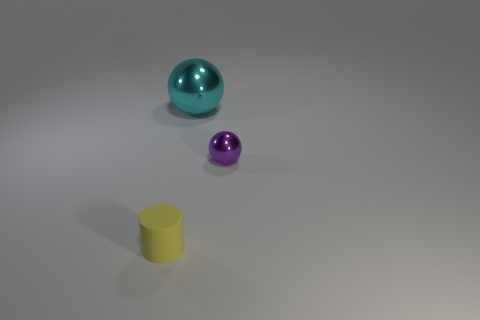Is the tiny purple thing made of the same material as the tiny yellow cylinder?
Your response must be concise. No. There is a small thing that is behind the tiny thing left of the thing that is behind the purple object; what is its material?
Give a very brief answer. Metal. How many things are either small objects in front of the tiny purple metal ball or objects right of the yellow matte cylinder?
Your response must be concise. 3. There is another large object that is the same shape as the purple object; what material is it?
Your answer should be compact. Metal. What number of metal things are either large cylinders or purple spheres?
Your response must be concise. 1. What number of other large cyan things are the same shape as the cyan thing?
Ensure brevity in your answer.  0. Does the thing that is left of the large ball have the same shape as the small thing that is behind the cylinder?
Your answer should be very brief. No. How many things are tiny purple metallic spheres or objects that are on the right side of the yellow cylinder?
Offer a very short reply. 2. How many objects are the same size as the cylinder?
Provide a short and direct response. 1. How many cyan things are either metal spheres or small rubber cylinders?
Keep it short and to the point. 1. 